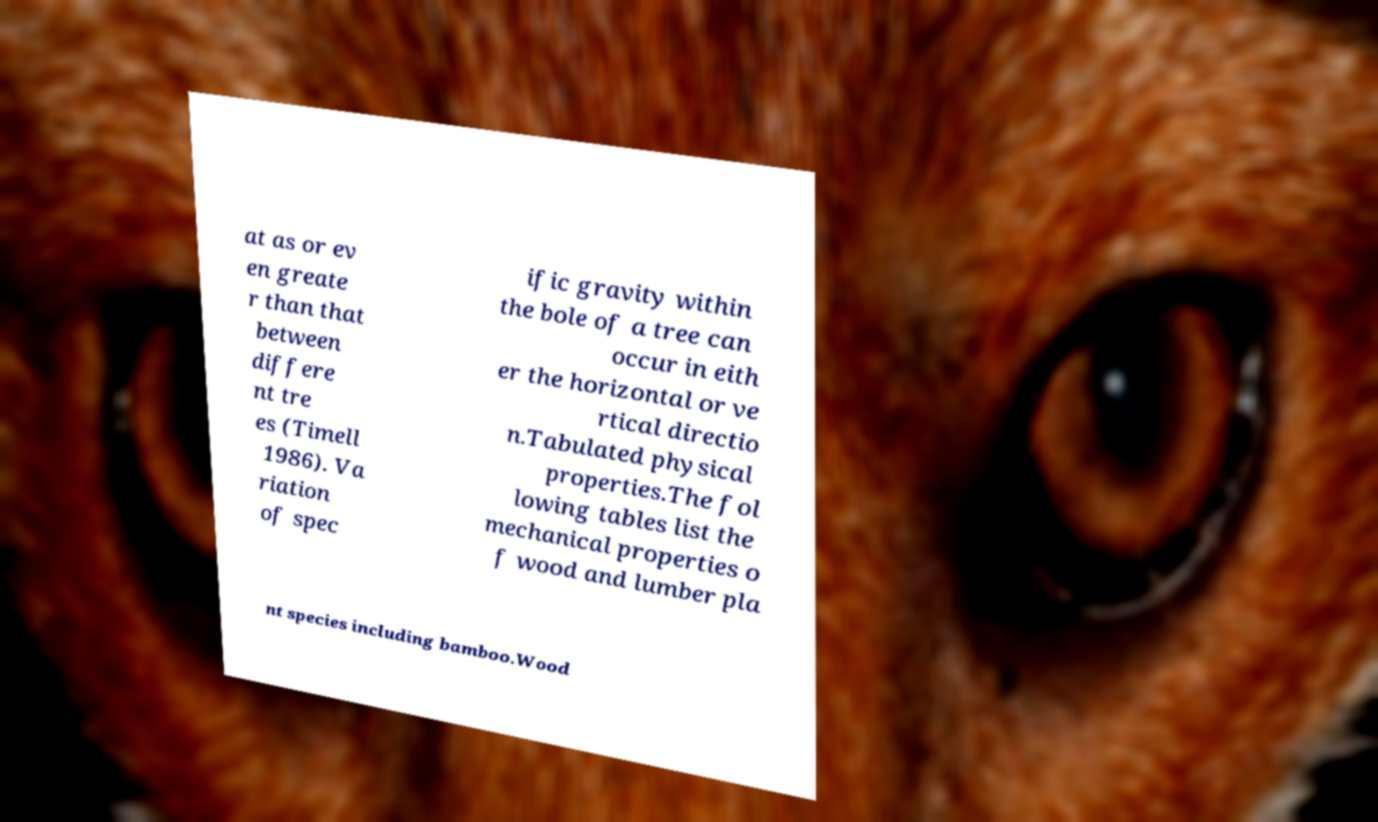Please identify and transcribe the text found in this image. at as or ev en greate r than that between differe nt tre es (Timell 1986). Va riation of spec ific gravity within the bole of a tree can occur in eith er the horizontal or ve rtical directio n.Tabulated physical properties.The fol lowing tables list the mechanical properties o f wood and lumber pla nt species including bamboo.Wood 